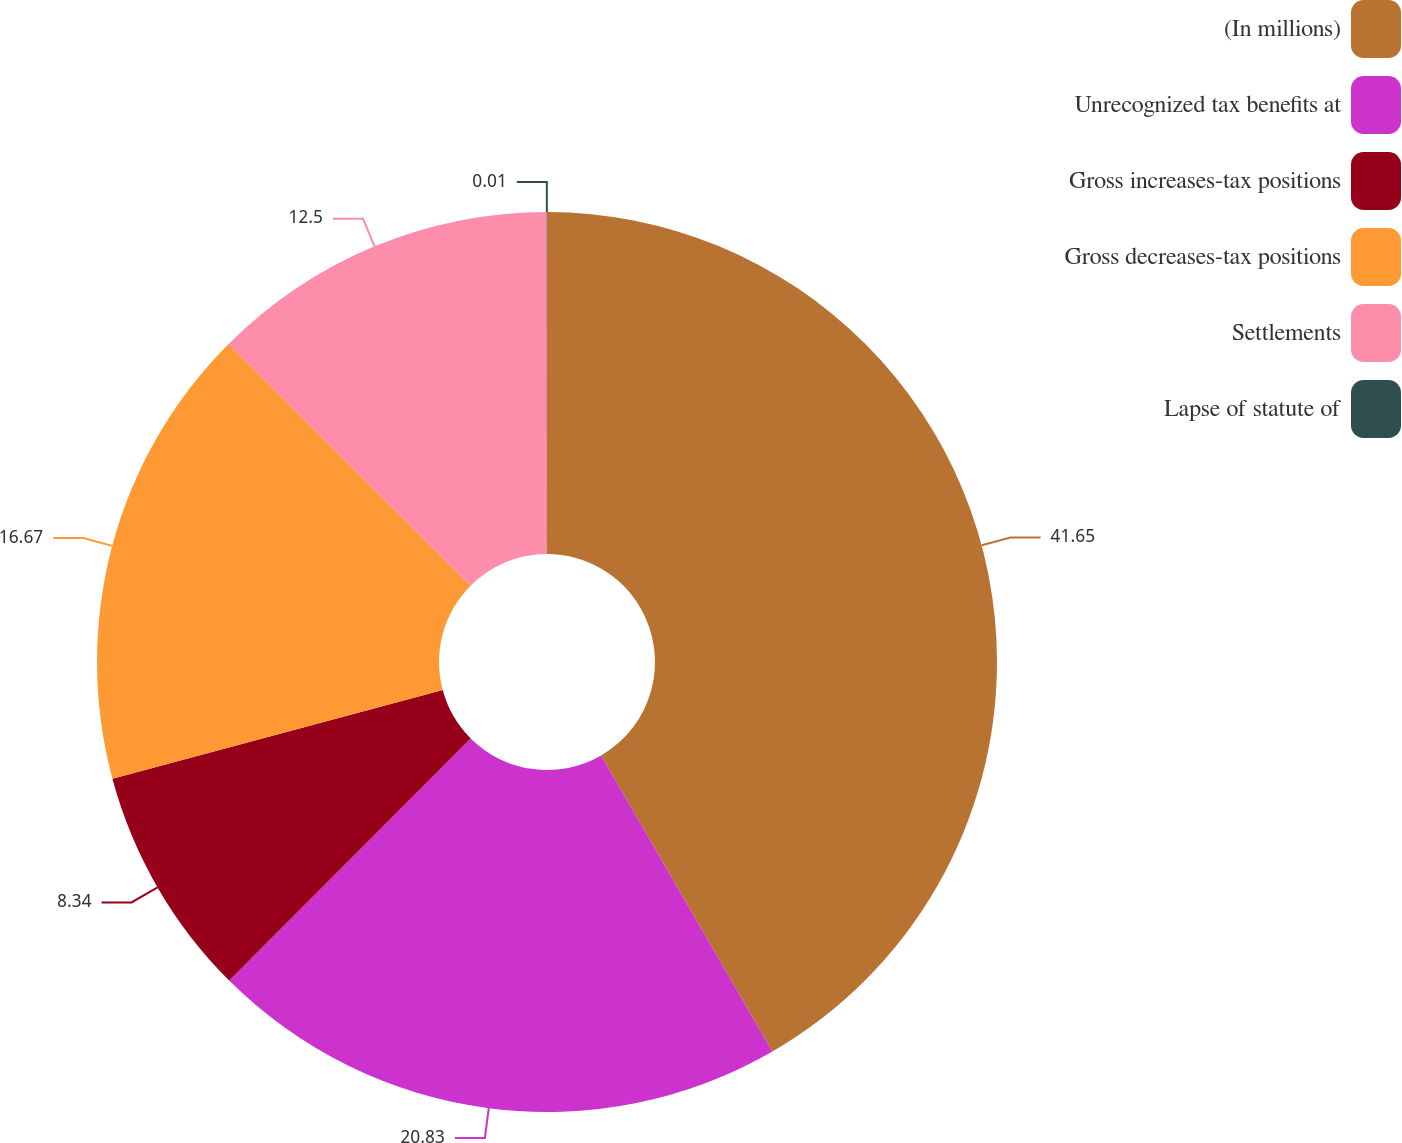Convert chart to OTSL. <chart><loc_0><loc_0><loc_500><loc_500><pie_chart><fcel>(In millions)<fcel>Unrecognized tax benefits at<fcel>Gross increases-tax positions<fcel>Gross decreases-tax positions<fcel>Settlements<fcel>Lapse of statute of<nl><fcel>41.65%<fcel>20.83%<fcel>8.34%<fcel>16.67%<fcel>12.5%<fcel>0.01%<nl></chart> 